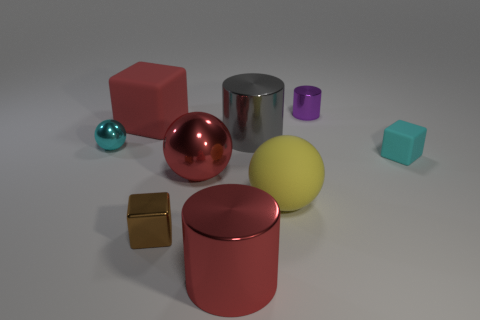The cylinder that is behind the brown object and to the left of the purple cylinder is made of what material?
Provide a succinct answer. Metal. Do the large gray cylinder and the cube left of the small metallic block have the same material?
Provide a succinct answer. No. Are there more big red metallic spheres that are in front of the small purple thing than big red rubber objects that are right of the big matte cube?
Provide a succinct answer. Yes. The big gray object is what shape?
Keep it short and to the point. Cylinder. Do the small cyan object that is left of the cyan matte cube and the small cyan object that is on the right side of the big rubber cube have the same material?
Your response must be concise. No. What shape is the small metal object that is in front of the cyan ball?
Ensure brevity in your answer.  Cube. The cyan metal object that is the same shape as the big yellow rubber object is what size?
Provide a short and direct response. Small. Do the tiny ball and the tiny matte thing have the same color?
Your response must be concise. Yes. Is there anything else that has the same shape as the big yellow object?
Give a very brief answer. Yes. Are there any metal balls that are in front of the small block that is behind the yellow object?
Keep it short and to the point. Yes. 